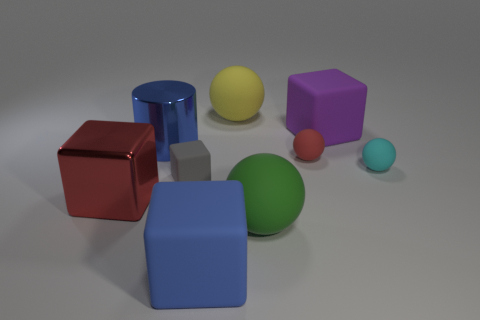There is a blue thing that is the same shape as the large purple rubber thing; what is its size?
Give a very brief answer. Large. Does the big blue thing in front of the big green ball have the same material as the large purple cube?
Ensure brevity in your answer.  Yes. The other big matte object that is the same shape as the big yellow rubber object is what color?
Your answer should be compact. Green. How many other things are the same color as the metal block?
Provide a short and direct response. 1. There is a large metallic object in front of the blue metal cylinder; is it the same shape as the blue thing right of the large blue shiny cylinder?
Offer a terse response. Yes. What number of balls are either tiny objects or blue matte things?
Offer a terse response. 2. Is the number of gray rubber things to the right of the cyan rubber ball less than the number of cyan matte balls?
Provide a short and direct response. Yes. How many other things are made of the same material as the tiny gray object?
Provide a short and direct response. 6. Do the blue cube and the yellow matte object have the same size?
Offer a very short reply. Yes. What number of objects are rubber objects behind the big blue matte block or purple metal cubes?
Offer a terse response. 6. 